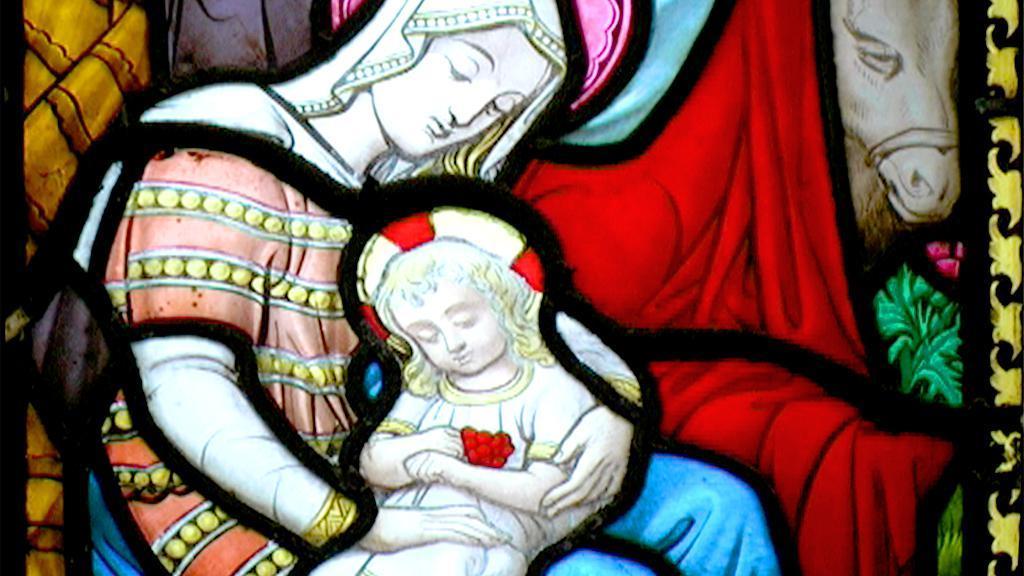In one or two sentences, can you explain what this image depicts? In the image we can see there is a painting of a person sitting and there is a kid sitting in the lap of the person. Behind there is a painting of a horse standing. 